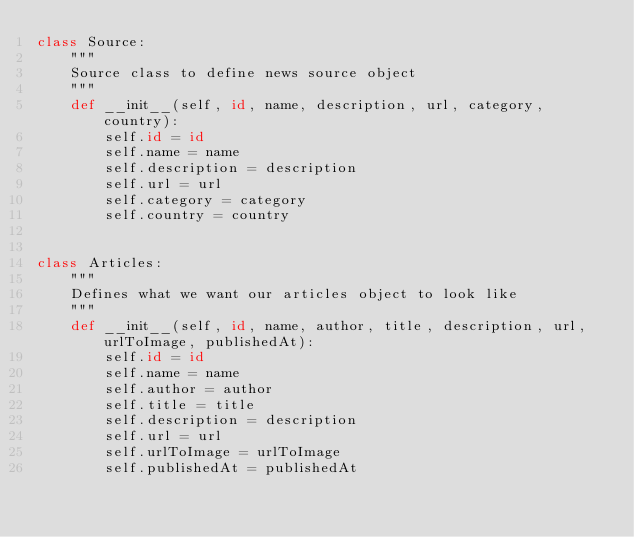Convert code to text. <code><loc_0><loc_0><loc_500><loc_500><_Python_>class Source:
    """
    Source class to define news source object
    """
    def __init__(self, id, name, description, url, category, country):
        self.id = id
        self.name = name
        self.description = description
        self.url = url
        self.category = category
        self.country = country


class Articles:
    """
    Defines what we want our articles object to look like
    """
    def __init__(self, id, name, author, title, description, url,  urlToImage, publishedAt):
        self.id = id
        self.name = name
        self.author = author
        self.title = title
        self.description = description
        self.url = url
        self.urlToImage = urlToImage
        self.publishedAt = publishedAt
</code> 